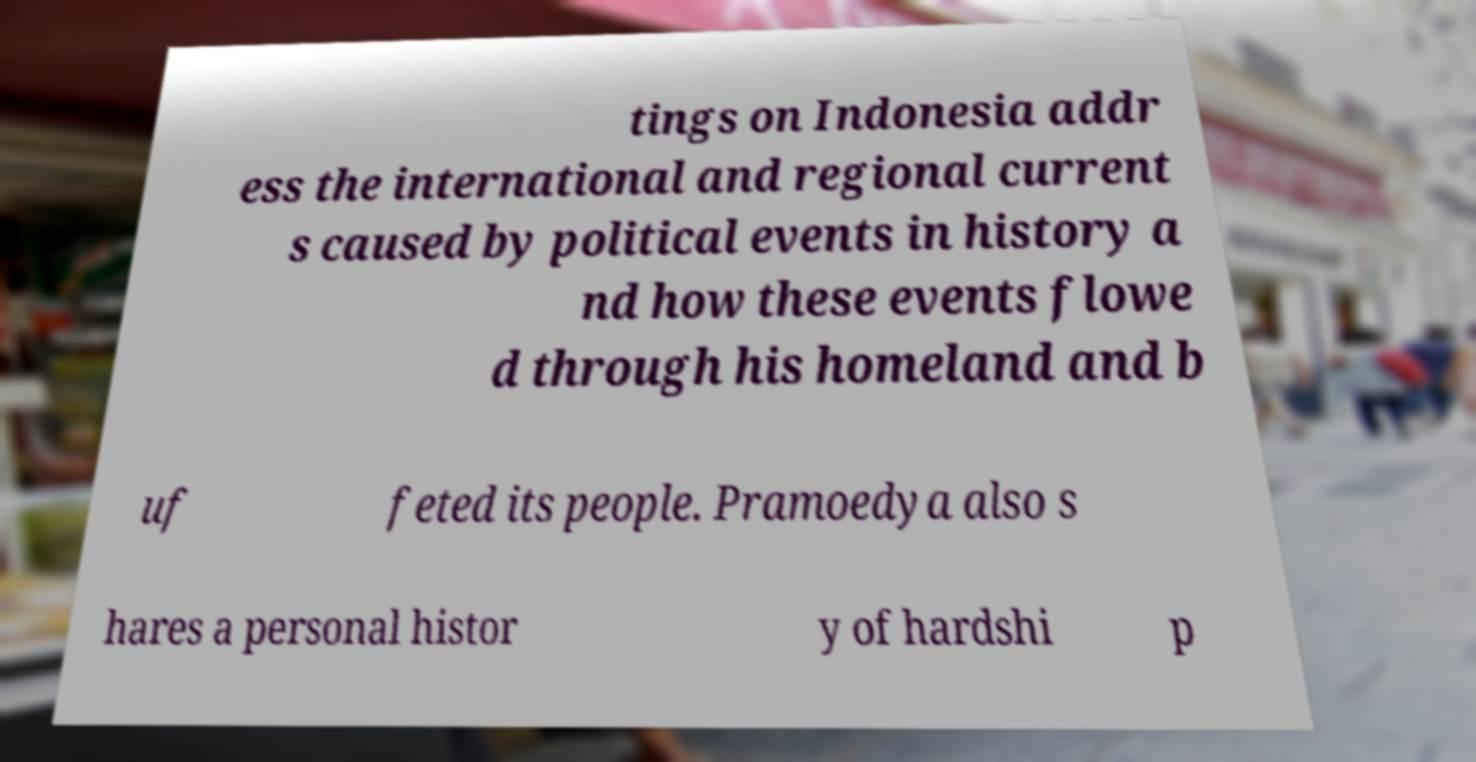Could you extract and type out the text from this image? tings on Indonesia addr ess the international and regional current s caused by political events in history a nd how these events flowe d through his homeland and b uf feted its people. Pramoedya also s hares a personal histor y of hardshi p 